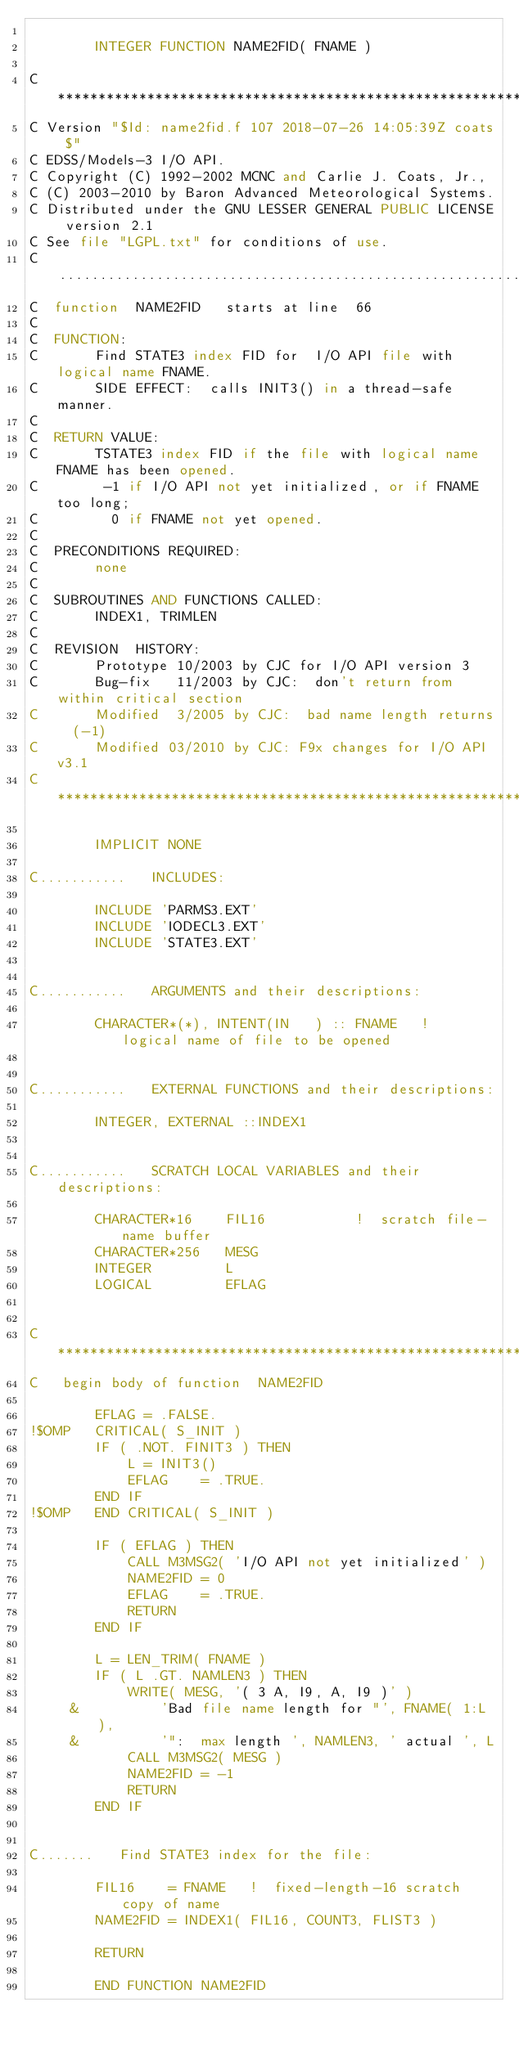Convert code to text. <code><loc_0><loc_0><loc_500><loc_500><_FORTRAN_>
        INTEGER FUNCTION NAME2FID( FNAME )

C***********************************************************************
C Version "$Id: name2fid.f 107 2018-07-26 14:05:39Z coats $"
C EDSS/Models-3 I/O API.
C Copyright (C) 1992-2002 MCNC and Carlie J. Coats, Jr.,
C (C) 2003-2010 by Baron Advanced Meteorological Systems.
C Distributed under the GNU LESSER GENERAL PUBLIC LICENSE version 2.1
C See file "LGPL.txt" for conditions of use.
C.........................................................................
C  function  NAME2FID   starts at line  66
C
C  FUNCTION:
C       Find STATE3 index FID for  I/O API file with logical name FNAME.
C       SIDE EFFECT:  calls INIT3() in a thread-safe manner.
C
C  RETURN VALUE:
C       TSTATE3 index FID if the file with logical name FNAME has been opened.
C        -1 if I/O API not yet initialized, or if FNAME too long;
C         0 if FNAME not yet opened.
C
C  PRECONDITIONS REQUIRED:
C       none
C
C  SUBROUTINES AND FUNCTIONS CALLED:
C       INDEX1, TRIMLEN
C
C  REVISION  HISTORY:  
C       Prototype 10/2003 by CJC for I/O API version 3
C       Bug-fix   11/2003 by CJC:  don't return from within critical section
C       Modified  3/2005 by CJC:  bad name length returns  (-1)
C       Modified 03/2010 by CJC: F9x changes for I/O API v3.1
C***********************************************************************

        IMPLICIT NONE

C...........   INCLUDES:

        INCLUDE 'PARMS3.EXT'
        INCLUDE 'IODECL3.EXT'
        INCLUDE 'STATE3.EXT'


C...........   ARGUMENTS and their descriptions:

        CHARACTER*(*), INTENT(IN   ) :: FNAME   !  logical name of file to be opened


C...........   EXTERNAL FUNCTIONS and their descriptions:

        INTEGER, EXTERNAL ::INDEX1


C...........   SCRATCH LOCAL VARIABLES and their descriptions:

        CHARACTER*16    FIL16           !  scratch file-name buffer
        CHARACTER*256   MESG
        INTEGER         L
        LOGICAL         EFLAG


C***********************************************************************
C   begin body of function  NAME2FID

        EFLAG = .FALSE.
!$OMP   CRITICAL( S_INIT )
        IF ( .NOT. FINIT3 ) THEN
            L = INIT3()
            EFLAG    = .TRUE.
        END IF
!$OMP   END CRITICAL( S_INIT )

        IF ( EFLAG ) THEN
            CALL M3MSG2( 'I/O API not yet initialized' )
            NAME2FID = 0
            EFLAG    = .TRUE.
            RETURN
        END IF

        L = LEN_TRIM( FNAME )
        IF ( L .GT. NAMLEN3 ) THEN
            WRITE( MESG, '( 3 A, I9, A, I9 )' )
     &          'Bad file name length for "', FNAME( 1:L ),
     &          '":  max length ', NAMLEN3, ' actual ', L
            CALL M3MSG2( MESG )
            NAME2FID = -1
            RETURN
        END IF
        

C.......   Find STATE3 index for the file:

        FIL16    = FNAME   !  fixed-length-16 scratch copy of name
        NAME2FID = INDEX1( FIL16, COUNT3, FLIST3 )

        RETURN

        END FUNCTION NAME2FID


</code> 